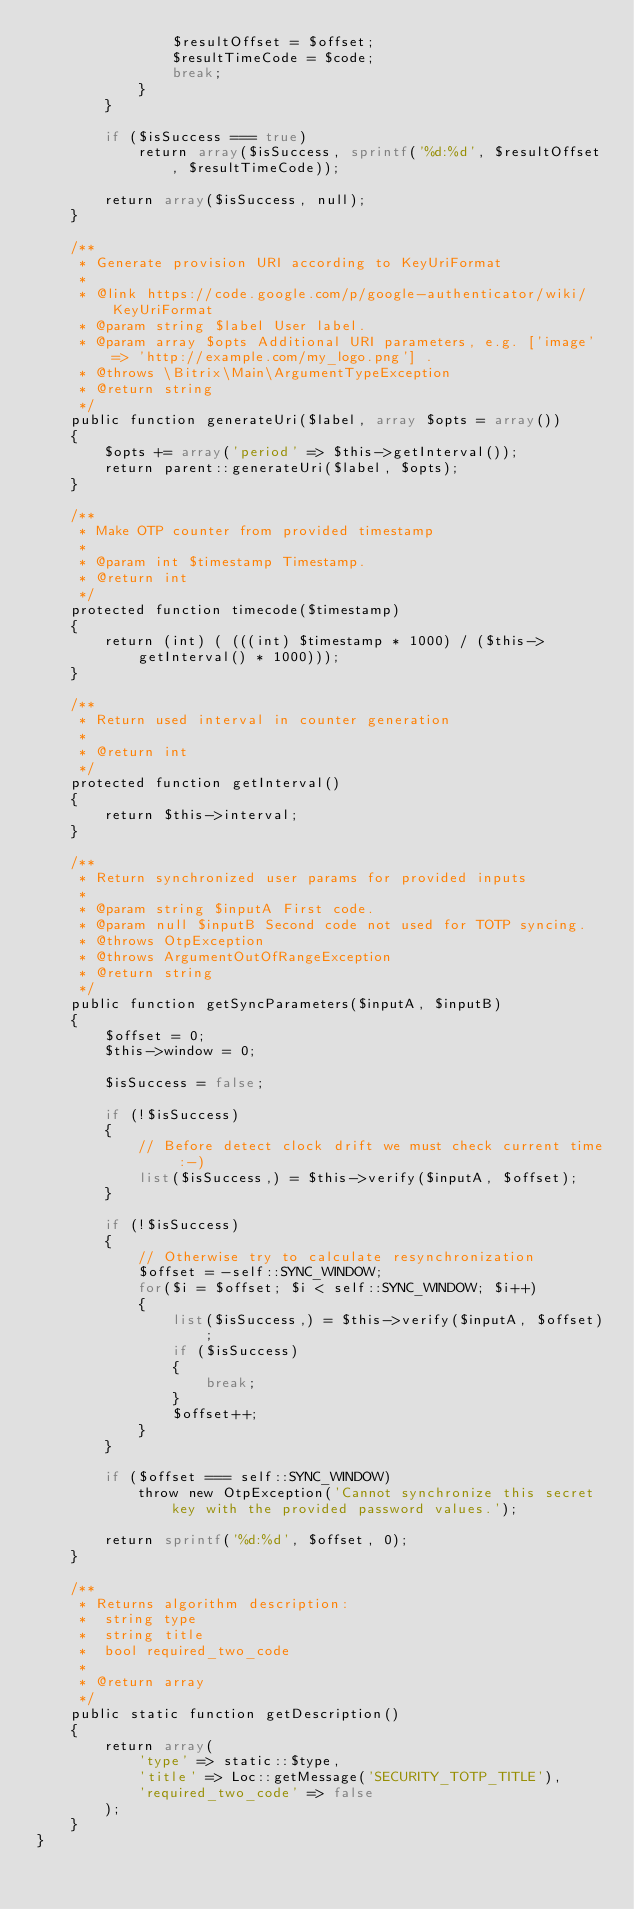<code> <loc_0><loc_0><loc_500><loc_500><_PHP_>				$resultOffset = $offset;
				$resultTimeCode = $code;
				break;
			}
		}

		if ($isSuccess === true)
			return array($isSuccess, sprintf('%d:%d', $resultOffset, $resultTimeCode));

		return array($isSuccess, null);
	}

	/**
	 * Generate provision URI according to KeyUriFormat
	 *
	 * @link https://code.google.com/p/google-authenticator/wiki/KeyUriFormat
	 * @param string $label User label.
	 * @param array $opts Additional URI parameters, e.g. ['image' => 'http://example.com/my_logo.png'] .
	 * @throws \Bitrix\Main\ArgumentTypeException
	 * @return string
	 */
	public function generateUri($label, array $opts = array())
	{
		$opts += array('period' => $this->getInterval());
		return parent::generateUri($label, $opts);
	}

	/**
	 * Make OTP counter from provided timestamp
	 *
	 * @param int $timestamp Timestamp.
	 * @return int
	 */
	protected function timecode($timestamp)
	{
		return (int) ( (((int) $timestamp * 1000) / ($this->getInterval() * 1000)));
	}

	/**
	 * Return used interval in counter generation
	 *
	 * @return int
	 */
	protected function getInterval()
	{
		return $this->interval;
	}

	/**
	 * Return synchronized user params for provided inputs
	 *
	 * @param string $inputA First code.
	 * @param null $inputB Second code not used for TOTP syncing.
	 * @throws OtpException
	 * @throws ArgumentOutOfRangeException
	 * @return string
	 */
	public function getSyncParameters($inputA, $inputB)
	{
		$offset = 0;
		$this->window = 0;

		$isSuccess = false;

		if (!$isSuccess)
		{
			// Before detect clock drift we must check current time :-)
			list($isSuccess,) = $this->verify($inputA, $offset);
		}

		if (!$isSuccess)
		{
			// Otherwise try to calculate resynchronization
			$offset = -self::SYNC_WINDOW;
			for($i = $offset; $i < self::SYNC_WINDOW; $i++)
			{
				list($isSuccess,) = $this->verify($inputA, $offset);
				if ($isSuccess)
				{
					break;
				}
				$offset++;
			}
		}

		if ($offset === self::SYNC_WINDOW)
			throw new OtpException('Cannot synchronize this secret key with the provided password values.');

		return sprintf('%d:%d', $offset, 0);
	}

	/**
	 * Returns algorithm description:
	 *  string type
	 *  string title
	 *  bool required_two_code
	 *
	 * @return array
	 */
	public static function getDescription()
	{
		return array(
			'type' => static::$type,
			'title' => Loc::getMessage('SECURITY_TOTP_TITLE'),
			'required_two_code' => false
		);
	}
}
</code> 